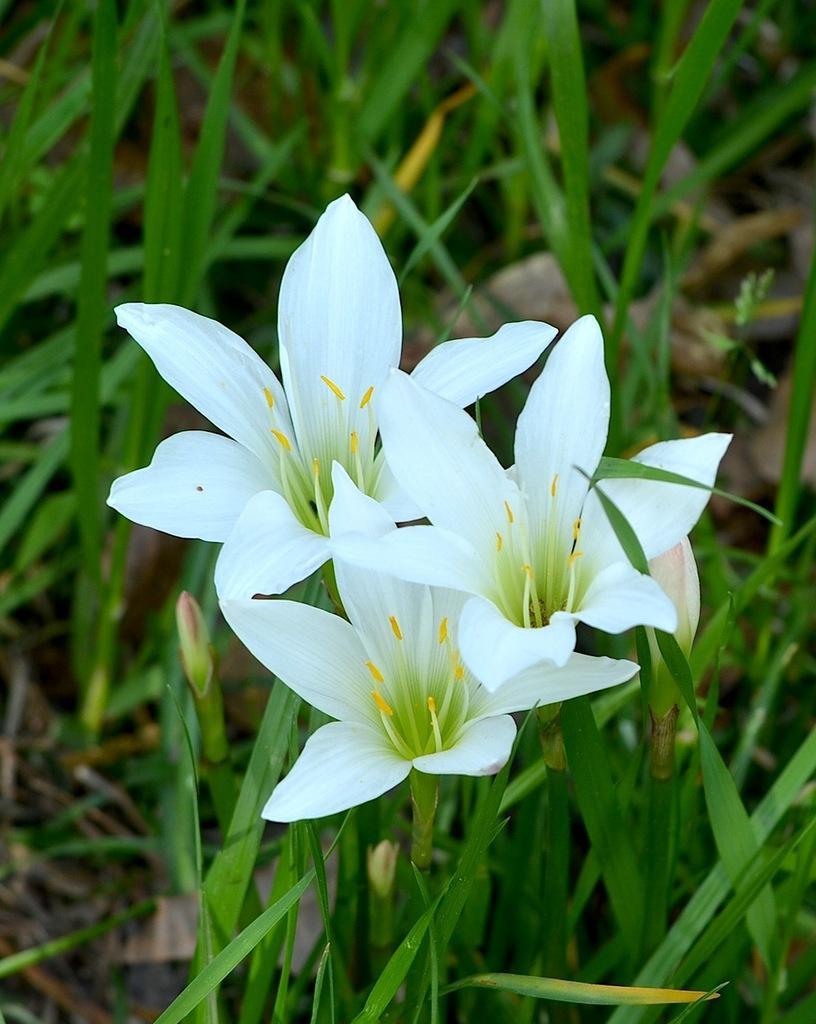Describe this image in one or two sentences. In the middle of this image, there are three white color flowers of the plants. In the background, there are other plants. 